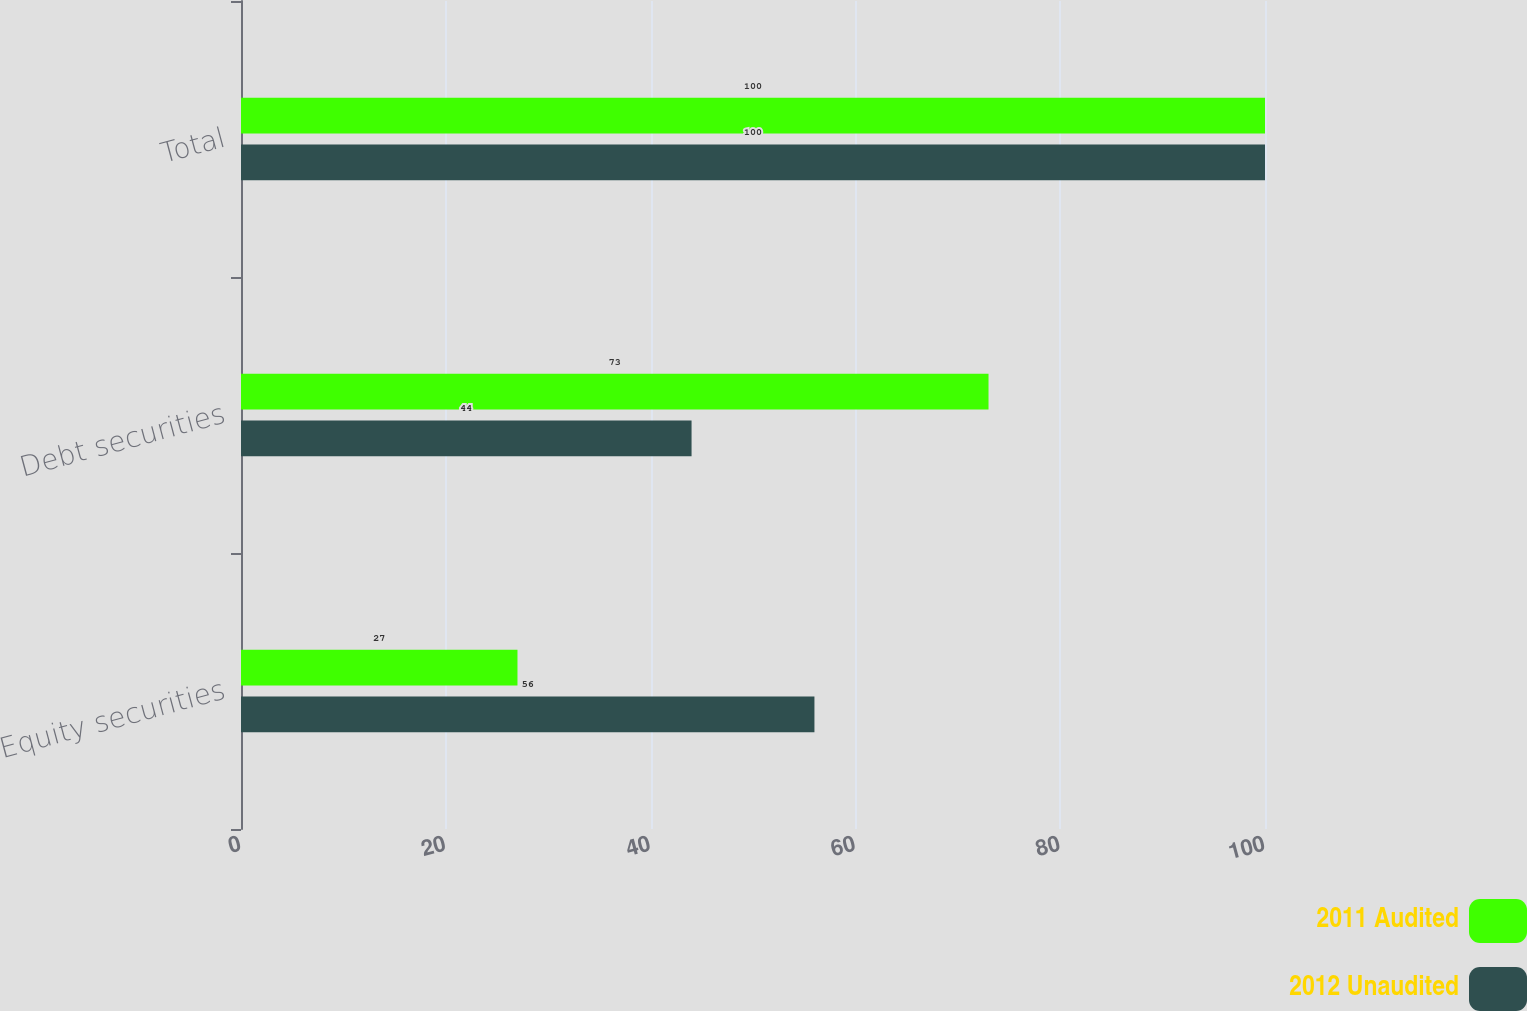<chart> <loc_0><loc_0><loc_500><loc_500><stacked_bar_chart><ecel><fcel>Equity securities<fcel>Debt securities<fcel>Total<nl><fcel>2011 Audited<fcel>27<fcel>73<fcel>100<nl><fcel>2012 Unaudited<fcel>56<fcel>44<fcel>100<nl></chart> 